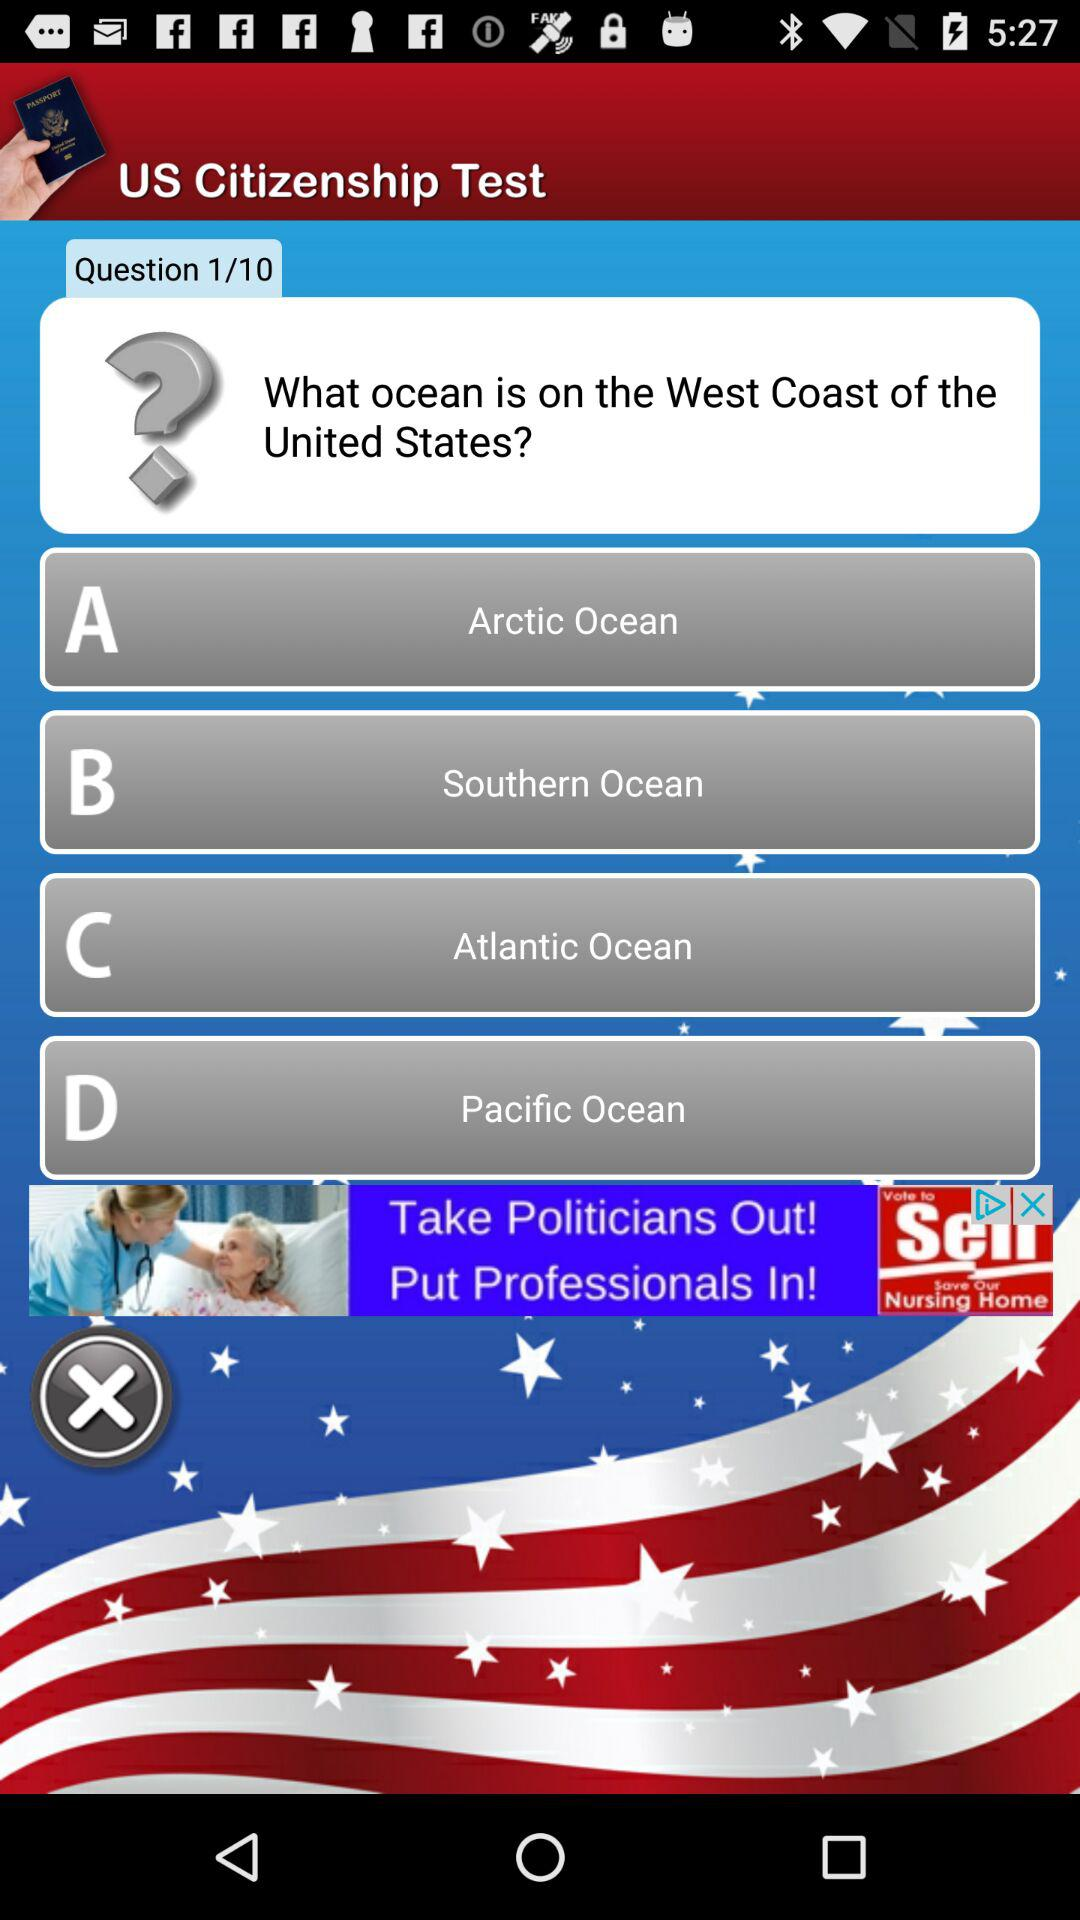Which question of the "US citizenship test" am I on? You are on question one of the "US citizenship test". 